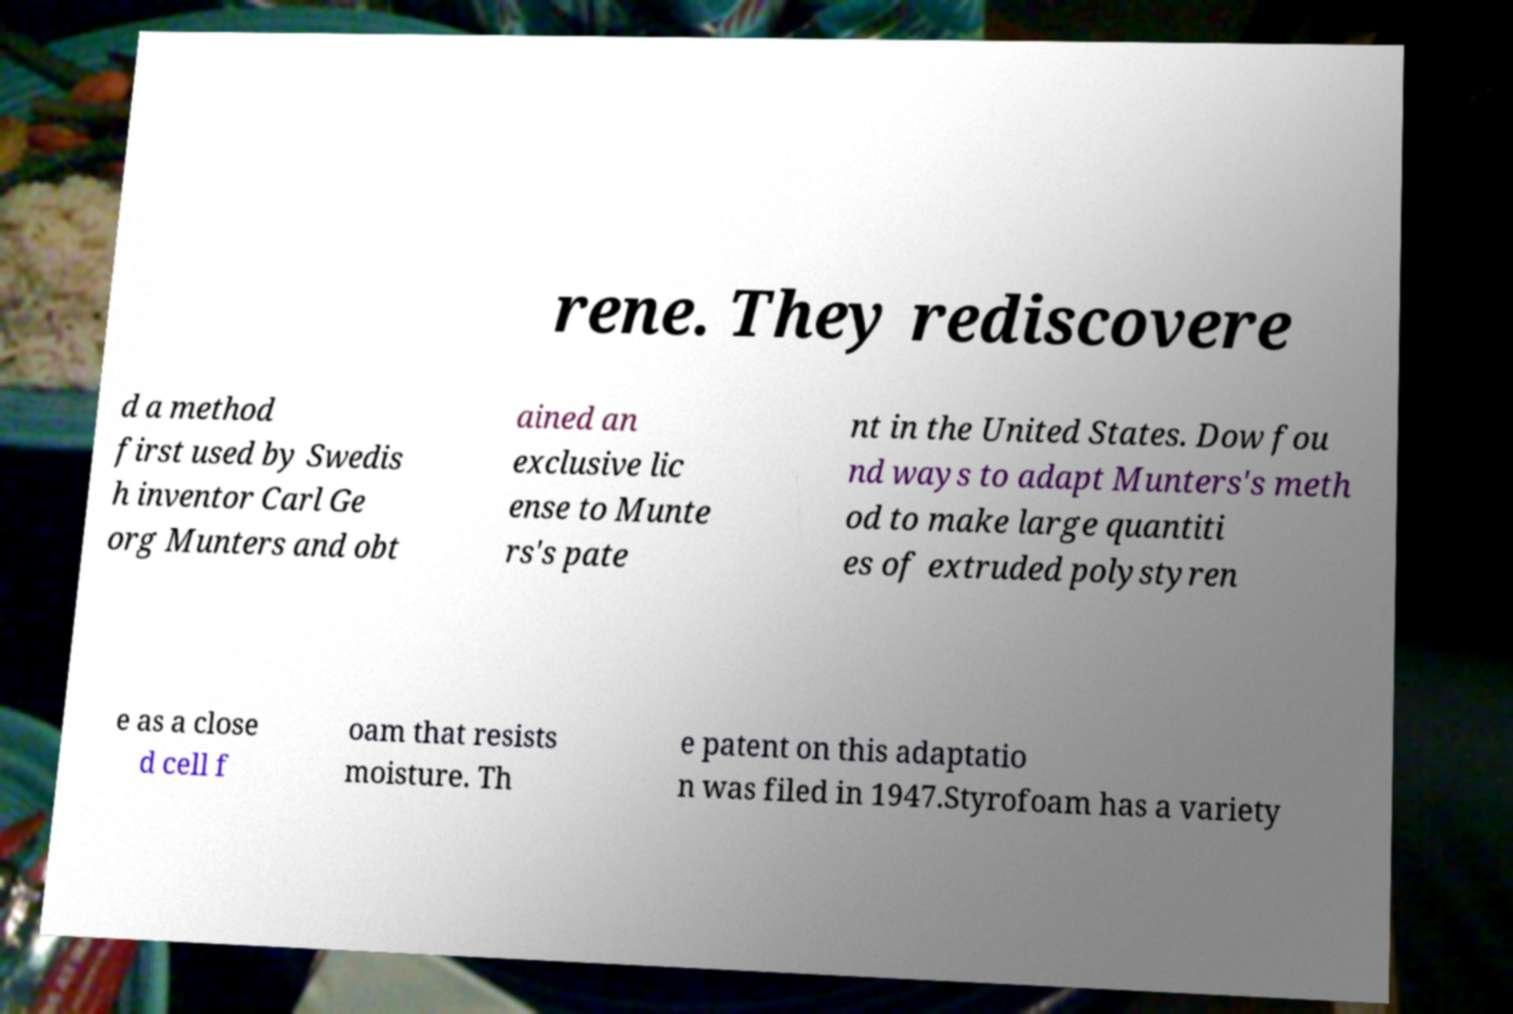What messages or text are displayed in this image? I need them in a readable, typed format. rene. They rediscovere d a method first used by Swedis h inventor Carl Ge org Munters and obt ained an exclusive lic ense to Munte rs's pate nt in the United States. Dow fou nd ways to adapt Munters's meth od to make large quantiti es of extruded polystyren e as a close d cell f oam that resists moisture. Th e patent on this adaptatio n was filed in 1947.Styrofoam has a variety 